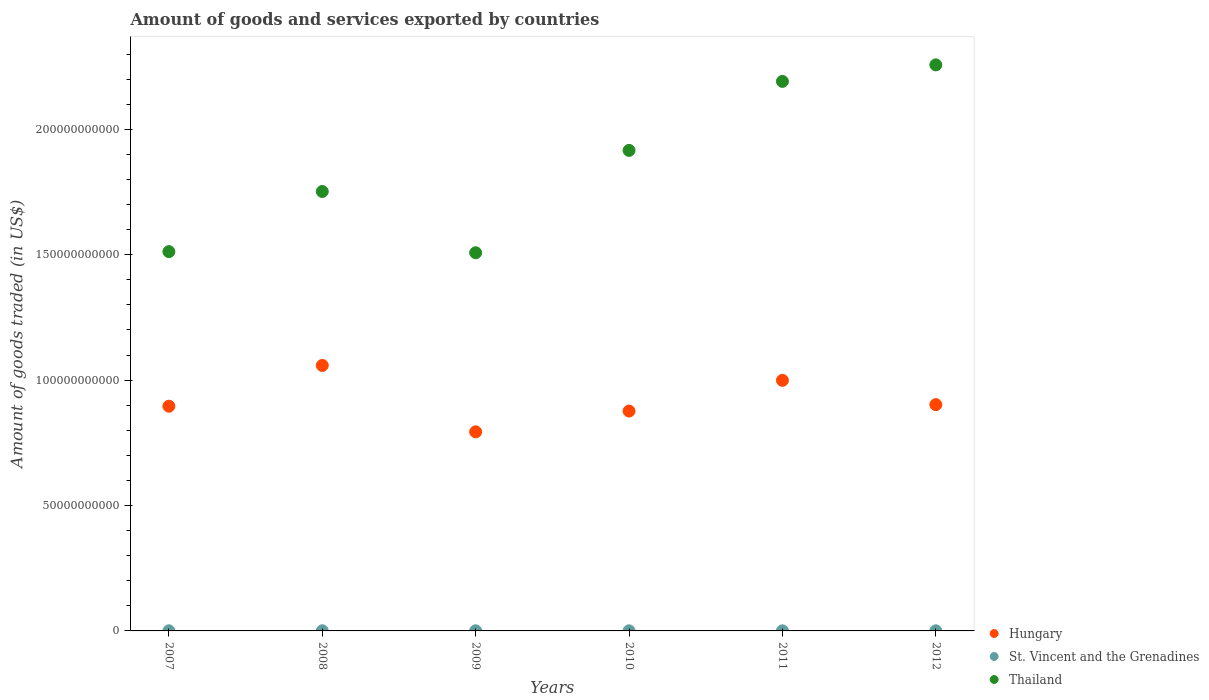How many different coloured dotlines are there?
Offer a terse response. 3. Is the number of dotlines equal to the number of legend labels?
Your answer should be very brief. Yes. What is the total amount of goods and services exported in St. Vincent and the Grenadines in 2012?
Make the answer very short. 4.78e+07. Across all years, what is the maximum total amount of goods and services exported in St. Vincent and the Grenadines?
Provide a succinct answer. 5.72e+07. Across all years, what is the minimum total amount of goods and services exported in St. Vincent and the Grenadines?
Your response must be concise. 4.34e+07. In which year was the total amount of goods and services exported in Thailand minimum?
Ensure brevity in your answer.  2009. What is the total total amount of goods and services exported in St. Vincent and the Grenadines in the graph?
Offer a terse response. 2.98e+08. What is the difference between the total amount of goods and services exported in St. Vincent and the Grenadines in 2009 and that in 2012?
Offer a terse response. 5.57e+06. What is the difference between the total amount of goods and services exported in Hungary in 2009 and the total amount of goods and services exported in St. Vincent and the Grenadines in 2008?
Your answer should be very brief. 7.93e+1. What is the average total amount of goods and services exported in Hungary per year?
Give a very brief answer. 9.21e+1. In the year 2009, what is the difference between the total amount of goods and services exported in St. Vincent and the Grenadines and total amount of goods and services exported in Hungary?
Offer a very short reply. -7.93e+1. What is the ratio of the total amount of goods and services exported in Thailand in 2008 to that in 2009?
Keep it short and to the point. 1.16. Is the difference between the total amount of goods and services exported in St. Vincent and the Grenadines in 2009 and 2012 greater than the difference between the total amount of goods and services exported in Hungary in 2009 and 2012?
Your answer should be very brief. Yes. What is the difference between the highest and the second highest total amount of goods and services exported in St. Vincent and the Grenadines?
Provide a short and direct response. 3.83e+06. What is the difference between the highest and the lowest total amount of goods and services exported in St. Vincent and the Grenadines?
Give a very brief answer. 1.38e+07. In how many years, is the total amount of goods and services exported in Hungary greater than the average total amount of goods and services exported in Hungary taken over all years?
Offer a terse response. 2. Is the sum of the total amount of goods and services exported in Thailand in 2008 and 2010 greater than the maximum total amount of goods and services exported in Hungary across all years?
Ensure brevity in your answer.  Yes. Is it the case that in every year, the sum of the total amount of goods and services exported in Hungary and total amount of goods and services exported in Thailand  is greater than the total amount of goods and services exported in St. Vincent and the Grenadines?
Give a very brief answer. Yes. Is the total amount of goods and services exported in Hungary strictly greater than the total amount of goods and services exported in Thailand over the years?
Give a very brief answer. No. Is the total amount of goods and services exported in Hungary strictly less than the total amount of goods and services exported in St. Vincent and the Grenadines over the years?
Offer a terse response. No. How many dotlines are there?
Your answer should be compact. 3. What is the difference between two consecutive major ticks on the Y-axis?
Your answer should be very brief. 5.00e+1. Does the graph contain grids?
Provide a succinct answer. No. Where does the legend appear in the graph?
Offer a terse response. Bottom right. What is the title of the graph?
Provide a short and direct response. Amount of goods and services exported by countries. Does "Kyrgyz Republic" appear as one of the legend labels in the graph?
Ensure brevity in your answer.  No. What is the label or title of the Y-axis?
Provide a short and direct response. Amount of goods traded (in US$). What is the Amount of goods traded (in US$) in Hungary in 2007?
Keep it short and to the point. 8.96e+1. What is the Amount of goods traded (in US$) of St. Vincent and the Grenadines in 2007?
Your response must be concise. 5.13e+07. What is the Amount of goods traded (in US$) of Thailand in 2007?
Your answer should be very brief. 1.51e+11. What is the Amount of goods traded (in US$) in Hungary in 2008?
Your answer should be very brief. 1.06e+11. What is the Amount of goods traded (in US$) of St. Vincent and the Grenadines in 2008?
Your response must be concise. 5.72e+07. What is the Amount of goods traded (in US$) in Thailand in 2008?
Keep it short and to the point. 1.75e+11. What is the Amount of goods traded (in US$) in Hungary in 2009?
Give a very brief answer. 7.94e+1. What is the Amount of goods traded (in US$) in St. Vincent and the Grenadines in 2009?
Keep it short and to the point. 5.34e+07. What is the Amount of goods traded (in US$) in Thailand in 2009?
Your answer should be compact. 1.51e+11. What is the Amount of goods traded (in US$) in Hungary in 2010?
Ensure brevity in your answer.  8.77e+1. What is the Amount of goods traded (in US$) of St. Vincent and the Grenadines in 2010?
Keep it short and to the point. 4.50e+07. What is the Amount of goods traded (in US$) in Thailand in 2010?
Offer a terse response. 1.92e+11. What is the Amount of goods traded (in US$) of Hungary in 2011?
Give a very brief answer. 9.99e+1. What is the Amount of goods traded (in US$) in St. Vincent and the Grenadines in 2011?
Give a very brief answer. 4.34e+07. What is the Amount of goods traded (in US$) of Thailand in 2011?
Ensure brevity in your answer.  2.19e+11. What is the Amount of goods traded (in US$) of Hungary in 2012?
Your answer should be very brief. 9.02e+1. What is the Amount of goods traded (in US$) of St. Vincent and the Grenadines in 2012?
Keep it short and to the point. 4.78e+07. What is the Amount of goods traded (in US$) in Thailand in 2012?
Ensure brevity in your answer.  2.26e+11. Across all years, what is the maximum Amount of goods traded (in US$) of Hungary?
Provide a succinct answer. 1.06e+11. Across all years, what is the maximum Amount of goods traded (in US$) of St. Vincent and the Grenadines?
Keep it short and to the point. 5.72e+07. Across all years, what is the maximum Amount of goods traded (in US$) in Thailand?
Provide a short and direct response. 2.26e+11. Across all years, what is the minimum Amount of goods traded (in US$) of Hungary?
Your answer should be compact. 7.94e+1. Across all years, what is the minimum Amount of goods traded (in US$) of St. Vincent and the Grenadines?
Provide a short and direct response. 4.34e+07. Across all years, what is the minimum Amount of goods traded (in US$) of Thailand?
Your answer should be very brief. 1.51e+11. What is the total Amount of goods traded (in US$) in Hungary in the graph?
Your answer should be very brief. 5.53e+11. What is the total Amount of goods traded (in US$) of St. Vincent and the Grenadines in the graph?
Provide a short and direct response. 2.98e+08. What is the total Amount of goods traded (in US$) in Thailand in the graph?
Your response must be concise. 1.11e+12. What is the difference between the Amount of goods traded (in US$) in Hungary in 2007 and that in 2008?
Offer a very short reply. -1.63e+1. What is the difference between the Amount of goods traded (in US$) in St. Vincent and the Grenadines in 2007 and that in 2008?
Keep it short and to the point. -5.84e+06. What is the difference between the Amount of goods traded (in US$) in Thailand in 2007 and that in 2008?
Provide a short and direct response. -2.40e+1. What is the difference between the Amount of goods traded (in US$) in Hungary in 2007 and that in 2009?
Make the answer very short. 1.02e+1. What is the difference between the Amount of goods traded (in US$) of St. Vincent and the Grenadines in 2007 and that in 2009?
Your response must be concise. -2.00e+06. What is the difference between the Amount of goods traded (in US$) of Thailand in 2007 and that in 2009?
Provide a succinct answer. 4.52e+08. What is the difference between the Amount of goods traded (in US$) of Hungary in 2007 and that in 2010?
Provide a succinct answer. 1.94e+09. What is the difference between the Amount of goods traded (in US$) in St. Vincent and the Grenadines in 2007 and that in 2010?
Make the answer very short. 6.35e+06. What is the difference between the Amount of goods traded (in US$) of Thailand in 2007 and that in 2010?
Make the answer very short. -4.04e+1. What is the difference between the Amount of goods traded (in US$) in Hungary in 2007 and that in 2011?
Offer a very short reply. -1.03e+1. What is the difference between the Amount of goods traded (in US$) of St. Vincent and the Grenadines in 2007 and that in 2011?
Keep it short and to the point. 7.93e+06. What is the difference between the Amount of goods traded (in US$) of Thailand in 2007 and that in 2011?
Offer a very short reply. -6.79e+1. What is the difference between the Amount of goods traded (in US$) in Hungary in 2007 and that in 2012?
Your answer should be compact. -6.25e+08. What is the difference between the Amount of goods traded (in US$) of St. Vincent and the Grenadines in 2007 and that in 2012?
Keep it short and to the point. 3.56e+06. What is the difference between the Amount of goods traded (in US$) in Thailand in 2007 and that in 2012?
Keep it short and to the point. -7.45e+1. What is the difference between the Amount of goods traded (in US$) of Hungary in 2008 and that in 2009?
Provide a short and direct response. 2.65e+1. What is the difference between the Amount of goods traded (in US$) of St. Vincent and the Grenadines in 2008 and that in 2009?
Provide a succinct answer. 3.83e+06. What is the difference between the Amount of goods traded (in US$) of Thailand in 2008 and that in 2009?
Provide a succinct answer. 2.44e+1. What is the difference between the Amount of goods traded (in US$) in Hungary in 2008 and that in 2010?
Your response must be concise. 1.82e+1. What is the difference between the Amount of goods traded (in US$) in St. Vincent and the Grenadines in 2008 and that in 2010?
Give a very brief answer. 1.22e+07. What is the difference between the Amount of goods traded (in US$) of Thailand in 2008 and that in 2010?
Provide a short and direct response. -1.64e+1. What is the difference between the Amount of goods traded (in US$) of Hungary in 2008 and that in 2011?
Make the answer very short. 5.95e+09. What is the difference between the Amount of goods traded (in US$) of St. Vincent and the Grenadines in 2008 and that in 2011?
Offer a terse response. 1.38e+07. What is the difference between the Amount of goods traded (in US$) of Thailand in 2008 and that in 2011?
Offer a very short reply. -4.39e+1. What is the difference between the Amount of goods traded (in US$) in Hungary in 2008 and that in 2012?
Your answer should be very brief. 1.56e+1. What is the difference between the Amount of goods traded (in US$) in St. Vincent and the Grenadines in 2008 and that in 2012?
Give a very brief answer. 9.40e+06. What is the difference between the Amount of goods traded (in US$) in Thailand in 2008 and that in 2012?
Offer a terse response. -5.05e+1. What is the difference between the Amount of goods traded (in US$) of Hungary in 2009 and that in 2010?
Ensure brevity in your answer.  -8.29e+09. What is the difference between the Amount of goods traded (in US$) of St. Vincent and the Grenadines in 2009 and that in 2010?
Your answer should be very brief. 8.35e+06. What is the difference between the Amount of goods traded (in US$) of Thailand in 2009 and that in 2010?
Give a very brief answer. -4.08e+1. What is the difference between the Amount of goods traded (in US$) of Hungary in 2009 and that in 2011?
Give a very brief answer. -2.05e+1. What is the difference between the Amount of goods traded (in US$) of St. Vincent and the Grenadines in 2009 and that in 2011?
Your answer should be compact. 9.93e+06. What is the difference between the Amount of goods traded (in US$) of Thailand in 2009 and that in 2011?
Offer a terse response. -6.83e+1. What is the difference between the Amount of goods traded (in US$) of Hungary in 2009 and that in 2012?
Provide a succinct answer. -1.08e+1. What is the difference between the Amount of goods traded (in US$) of St. Vincent and the Grenadines in 2009 and that in 2012?
Provide a short and direct response. 5.57e+06. What is the difference between the Amount of goods traded (in US$) of Thailand in 2009 and that in 2012?
Your answer should be compact. -7.49e+1. What is the difference between the Amount of goods traded (in US$) in Hungary in 2010 and that in 2011?
Make the answer very short. -1.22e+1. What is the difference between the Amount of goods traded (in US$) in St. Vincent and the Grenadines in 2010 and that in 2011?
Keep it short and to the point. 1.58e+06. What is the difference between the Amount of goods traded (in US$) of Thailand in 2010 and that in 2011?
Keep it short and to the point. -2.75e+1. What is the difference between the Amount of goods traded (in US$) of Hungary in 2010 and that in 2012?
Give a very brief answer. -2.56e+09. What is the difference between the Amount of goods traded (in US$) of St. Vincent and the Grenadines in 2010 and that in 2012?
Offer a terse response. -2.79e+06. What is the difference between the Amount of goods traded (in US$) of Thailand in 2010 and that in 2012?
Your response must be concise. -3.41e+1. What is the difference between the Amount of goods traded (in US$) in Hungary in 2011 and that in 2012?
Keep it short and to the point. 9.68e+09. What is the difference between the Amount of goods traded (in US$) in St. Vincent and the Grenadines in 2011 and that in 2012?
Give a very brief answer. -4.37e+06. What is the difference between the Amount of goods traded (in US$) in Thailand in 2011 and that in 2012?
Give a very brief answer. -6.58e+09. What is the difference between the Amount of goods traded (in US$) of Hungary in 2007 and the Amount of goods traded (in US$) of St. Vincent and the Grenadines in 2008?
Your answer should be compact. 8.95e+1. What is the difference between the Amount of goods traded (in US$) of Hungary in 2007 and the Amount of goods traded (in US$) of Thailand in 2008?
Offer a terse response. -8.56e+1. What is the difference between the Amount of goods traded (in US$) of St. Vincent and the Grenadines in 2007 and the Amount of goods traded (in US$) of Thailand in 2008?
Keep it short and to the point. -1.75e+11. What is the difference between the Amount of goods traded (in US$) of Hungary in 2007 and the Amount of goods traded (in US$) of St. Vincent and the Grenadines in 2009?
Provide a short and direct response. 8.96e+1. What is the difference between the Amount of goods traded (in US$) of Hungary in 2007 and the Amount of goods traded (in US$) of Thailand in 2009?
Make the answer very short. -6.12e+1. What is the difference between the Amount of goods traded (in US$) in St. Vincent and the Grenadines in 2007 and the Amount of goods traded (in US$) in Thailand in 2009?
Make the answer very short. -1.51e+11. What is the difference between the Amount of goods traded (in US$) of Hungary in 2007 and the Amount of goods traded (in US$) of St. Vincent and the Grenadines in 2010?
Offer a very short reply. 8.96e+1. What is the difference between the Amount of goods traded (in US$) of Hungary in 2007 and the Amount of goods traded (in US$) of Thailand in 2010?
Your response must be concise. -1.02e+11. What is the difference between the Amount of goods traded (in US$) in St. Vincent and the Grenadines in 2007 and the Amount of goods traded (in US$) in Thailand in 2010?
Offer a very short reply. -1.92e+11. What is the difference between the Amount of goods traded (in US$) of Hungary in 2007 and the Amount of goods traded (in US$) of St. Vincent and the Grenadines in 2011?
Your answer should be compact. 8.96e+1. What is the difference between the Amount of goods traded (in US$) in Hungary in 2007 and the Amount of goods traded (in US$) in Thailand in 2011?
Offer a terse response. -1.30e+11. What is the difference between the Amount of goods traded (in US$) of St. Vincent and the Grenadines in 2007 and the Amount of goods traded (in US$) of Thailand in 2011?
Ensure brevity in your answer.  -2.19e+11. What is the difference between the Amount of goods traded (in US$) of Hungary in 2007 and the Amount of goods traded (in US$) of St. Vincent and the Grenadines in 2012?
Keep it short and to the point. 8.96e+1. What is the difference between the Amount of goods traded (in US$) in Hungary in 2007 and the Amount of goods traded (in US$) in Thailand in 2012?
Your answer should be very brief. -1.36e+11. What is the difference between the Amount of goods traded (in US$) in St. Vincent and the Grenadines in 2007 and the Amount of goods traded (in US$) in Thailand in 2012?
Keep it short and to the point. -2.26e+11. What is the difference between the Amount of goods traded (in US$) in Hungary in 2008 and the Amount of goods traded (in US$) in St. Vincent and the Grenadines in 2009?
Offer a terse response. 1.06e+11. What is the difference between the Amount of goods traded (in US$) in Hungary in 2008 and the Amount of goods traded (in US$) in Thailand in 2009?
Your answer should be compact. -4.49e+1. What is the difference between the Amount of goods traded (in US$) of St. Vincent and the Grenadines in 2008 and the Amount of goods traded (in US$) of Thailand in 2009?
Ensure brevity in your answer.  -1.51e+11. What is the difference between the Amount of goods traded (in US$) of Hungary in 2008 and the Amount of goods traded (in US$) of St. Vincent and the Grenadines in 2010?
Your response must be concise. 1.06e+11. What is the difference between the Amount of goods traded (in US$) of Hungary in 2008 and the Amount of goods traded (in US$) of Thailand in 2010?
Provide a succinct answer. -8.57e+1. What is the difference between the Amount of goods traded (in US$) of St. Vincent and the Grenadines in 2008 and the Amount of goods traded (in US$) of Thailand in 2010?
Offer a terse response. -1.92e+11. What is the difference between the Amount of goods traded (in US$) in Hungary in 2008 and the Amount of goods traded (in US$) in St. Vincent and the Grenadines in 2011?
Make the answer very short. 1.06e+11. What is the difference between the Amount of goods traded (in US$) in Hungary in 2008 and the Amount of goods traded (in US$) in Thailand in 2011?
Give a very brief answer. -1.13e+11. What is the difference between the Amount of goods traded (in US$) of St. Vincent and the Grenadines in 2008 and the Amount of goods traded (in US$) of Thailand in 2011?
Ensure brevity in your answer.  -2.19e+11. What is the difference between the Amount of goods traded (in US$) in Hungary in 2008 and the Amount of goods traded (in US$) in St. Vincent and the Grenadines in 2012?
Ensure brevity in your answer.  1.06e+11. What is the difference between the Amount of goods traded (in US$) of Hungary in 2008 and the Amount of goods traded (in US$) of Thailand in 2012?
Give a very brief answer. -1.20e+11. What is the difference between the Amount of goods traded (in US$) in St. Vincent and the Grenadines in 2008 and the Amount of goods traded (in US$) in Thailand in 2012?
Offer a terse response. -2.26e+11. What is the difference between the Amount of goods traded (in US$) in Hungary in 2009 and the Amount of goods traded (in US$) in St. Vincent and the Grenadines in 2010?
Your response must be concise. 7.93e+1. What is the difference between the Amount of goods traded (in US$) in Hungary in 2009 and the Amount of goods traded (in US$) in Thailand in 2010?
Provide a short and direct response. -1.12e+11. What is the difference between the Amount of goods traded (in US$) of St. Vincent and the Grenadines in 2009 and the Amount of goods traded (in US$) of Thailand in 2010?
Give a very brief answer. -1.92e+11. What is the difference between the Amount of goods traded (in US$) of Hungary in 2009 and the Amount of goods traded (in US$) of St. Vincent and the Grenadines in 2011?
Give a very brief answer. 7.93e+1. What is the difference between the Amount of goods traded (in US$) of Hungary in 2009 and the Amount of goods traded (in US$) of Thailand in 2011?
Ensure brevity in your answer.  -1.40e+11. What is the difference between the Amount of goods traded (in US$) of St. Vincent and the Grenadines in 2009 and the Amount of goods traded (in US$) of Thailand in 2011?
Offer a very short reply. -2.19e+11. What is the difference between the Amount of goods traded (in US$) of Hungary in 2009 and the Amount of goods traded (in US$) of St. Vincent and the Grenadines in 2012?
Your answer should be very brief. 7.93e+1. What is the difference between the Amount of goods traded (in US$) of Hungary in 2009 and the Amount of goods traded (in US$) of Thailand in 2012?
Provide a succinct answer. -1.46e+11. What is the difference between the Amount of goods traded (in US$) in St. Vincent and the Grenadines in 2009 and the Amount of goods traded (in US$) in Thailand in 2012?
Keep it short and to the point. -2.26e+11. What is the difference between the Amount of goods traded (in US$) in Hungary in 2010 and the Amount of goods traded (in US$) in St. Vincent and the Grenadines in 2011?
Your answer should be very brief. 8.76e+1. What is the difference between the Amount of goods traded (in US$) of Hungary in 2010 and the Amount of goods traded (in US$) of Thailand in 2011?
Keep it short and to the point. -1.31e+11. What is the difference between the Amount of goods traded (in US$) in St. Vincent and the Grenadines in 2010 and the Amount of goods traded (in US$) in Thailand in 2011?
Provide a succinct answer. -2.19e+11. What is the difference between the Amount of goods traded (in US$) of Hungary in 2010 and the Amount of goods traded (in US$) of St. Vincent and the Grenadines in 2012?
Your answer should be compact. 8.76e+1. What is the difference between the Amount of goods traded (in US$) in Hungary in 2010 and the Amount of goods traded (in US$) in Thailand in 2012?
Provide a short and direct response. -1.38e+11. What is the difference between the Amount of goods traded (in US$) in St. Vincent and the Grenadines in 2010 and the Amount of goods traded (in US$) in Thailand in 2012?
Keep it short and to the point. -2.26e+11. What is the difference between the Amount of goods traded (in US$) in Hungary in 2011 and the Amount of goods traded (in US$) in St. Vincent and the Grenadines in 2012?
Provide a succinct answer. 9.99e+1. What is the difference between the Amount of goods traded (in US$) in Hungary in 2011 and the Amount of goods traded (in US$) in Thailand in 2012?
Your answer should be very brief. -1.26e+11. What is the difference between the Amount of goods traded (in US$) in St. Vincent and the Grenadines in 2011 and the Amount of goods traded (in US$) in Thailand in 2012?
Give a very brief answer. -2.26e+11. What is the average Amount of goods traded (in US$) in Hungary per year?
Give a very brief answer. 9.21e+1. What is the average Amount of goods traded (in US$) in St. Vincent and the Grenadines per year?
Provide a short and direct response. 4.97e+07. What is the average Amount of goods traded (in US$) of Thailand per year?
Offer a very short reply. 1.86e+11. In the year 2007, what is the difference between the Amount of goods traded (in US$) of Hungary and Amount of goods traded (in US$) of St. Vincent and the Grenadines?
Offer a terse response. 8.96e+1. In the year 2007, what is the difference between the Amount of goods traded (in US$) in Hungary and Amount of goods traded (in US$) in Thailand?
Provide a short and direct response. -6.16e+1. In the year 2007, what is the difference between the Amount of goods traded (in US$) in St. Vincent and the Grenadines and Amount of goods traded (in US$) in Thailand?
Offer a terse response. -1.51e+11. In the year 2008, what is the difference between the Amount of goods traded (in US$) in Hungary and Amount of goods traded (in US$) in St. Vincent and the Grenadines?
Provide a short and direct response. 1.06e+11. In the year 2008, what is the difference between the Amount of goods traded (in US$) in Hungary and Amount of goods traded (in US$) in Thailand?
Your answer should be compact. -6.94e+1. In the year 2008, what is the difference between the Amount of goods traded (in US$) of St. Vincent and the Grenadines and Amount of goods traded (in US$) of Thailand?
Offer a terse response. -1.75e+11. In the year 2009, what is the difference between the Amount of goods traded (in US$) in Hungary and Amount of goods traded (in US$) in St. Vincent and the Grenadines?
Provide a succinct answer. 7.93e+1. In the year 2009, what is the difference between the Amount of goods traded (in US$) of Hungary and Amount of goods traded (in US$) of Thailand?
Give a very brief answer. -7.14e+1. In the year 2009, what is the difference between the Amount of goods traded (in US$) of St. Vincent and the Grenadines and Amount of goods traded (in US$) of Thailand?
Your response must be concise. -1.51e+11. In the year 2010, what is the difference between the Amount of goods traded (in US$) of Hungary and Amount of goods traded (in US$) of St. Vincent and the Grenadines?
Provide a succinct answer. 8.76e+1. In the year 2010, what is the difference between the Amount of goods traded (in US$) of Hungary and Amount of goods traded (in US$) of Thailand?
Provide a succinct answer. -1.04e+11. In the year 2010, what is the difference between the Amount of goods traded (in US$) of St. Vincent and the Grenadines and Amount of goods traded (in US$) of Thailand?
Your answer should be compact. -1.92e+11. In the year 2011, what is the difference between the Amount of goods traded (in US$) in Hungary and Amount of goods traded (in US$) in St. Vincent and the Grenadines?
Your answer should be very brief. 9.99e+1. In the year 2011, what is the difference between the Amount of goods traded (in US$) in Hungary and Amount of goods traded (in US$) in Thailand?
Give a very brief answer. -1.19e+11. In the year 2011, what is the difference between the Amount of goods traded (in US$) in St. Vincent and the Grenadines and Amount of goods traded (in US$) in Thailand?
Your response must be concise. -2.19e+11. In the year 2012, what is the difference between the Amount of goods traded (in US$) of Hungary and Amount of goods traded (in US$) of St. Vincent and the Grenadines?
Give a very brief answer. 9.02e+1. In the year 2012, what is the difference between the Amount of goods traded (in US$) of Hungary and Amount of goods traded (in US$) of Thailand?
Ensure brevity in your answer.  -1.35e+11. In the year 2012, what is the difference between the Amount of goods traded (in US$) in St. Vincent and the Grenadines and Amount of goods traded (in US$) in Thailand?
Provide a short and direct response. -2.26e+11. What is the ratio of the Amount of goods traded (in US$) of Hungary in 2007 to that in 2008?
Keep it short and to the point. 0.85. What is the ratio of the Amount of goods traded (in US$) of St. Vincent and the Grenadines in 2007 to that in 2008?
Keep it short and to the point. 0.9. What is the ratio of the Amount of goods traded (in US$) of Thailand in 2007 to that in 2008?
Provide a succinct answer. 0.86. What is the ratio of the Amount of goods traded (in US$) in Hungary in 2007 to that in 2009?
Ensure brevity in your answer.  1.13. What is the ratio of the Amount of goods traded (in US$) in St. Vincent and the Grenadines in 2007 to that in 2009?
Your answer should be very brief. 0.96. What is the ratio of the Amount of goods traded (in US$) of Thailand in 2007 to that in 2009?
Your answer should be compact. 1. What is the ratio of the Amount of goods traded (in US$) of Hungary in 2007 to that in 2010?
Provide a short and direct response. 1.02. What is the ratio of the Amount of goods traded (in US$) in St. Vincent and the Grenadines in 2007 to that in 2010?
Offer a terse response. 1.14. What is the ratio of the Amount of goods traded (in US$) of Thailand in 2007 to that in 2010?
Ensure brevity in your answer.  0.79. What is the ratio of the Amount of goods traded (in US$) of Hungary in 2007 to that in 2011?
Give a very brief answer. 0.9. What is the ratio of the Amount of goods traded (in US$) of St. Vincent and the Grenadines in 2007 to that in 2011?
Keep it short and to the point. 1.18. What is the ratio of the Amount of goods traded (in US$) in Thailand in 2007 to that in 2011?
Provide a succinct answer. 0.69. What is the ratio of the Amount of goods traded (in US$) of Hungary in 2007 to that in 2012?
Your answer should be compact. 0.99. What is the ratio of the Amount of goods traded (in US$) of St. Vincent and the Grenadines in 2007 to that in 2012?
Make the answer very short. 1.07. What is the ratio of the Amount of goods traded (in US$) in Thailand in 2007 to that in 2012?
Make the answer very short. 0.67. What is the ratio of the Amount of goods traded (in US$) in Hungary in 2008 to that in 2009?
Offer a terse response. 1.33. What is the ratio of the Amount of goods traded (in US$) of St. Vincent and the Grenadines in 2008 to that in 2009?
Your answer should be very brief. 1.07. What is the ratio of the Amount of goods traded (in US$) of Thailand in 2008 to that in 2009?
Keep it short and to the point. 1.16. What is the ratio of the Amount of goods traded (in US$) of Hungary in 2008 to that in 2010?
Offer a terse response. 1.21. What is the ratio of the Amount of goods traded (in US$) in St. Vincent and the Grenadines in 2008 to that in 2010?
Your response must be concise. 1.27. What is the ratio of the Amount of goods traded (in US$) of Thailand in 2008 to that in 2010?
Your answer should be compact. 0.91. What is the ratio of the Amount of goods traded (in US$) of Hungary in 2008 to that in 2011?
Your response must be concise. 1.06. What is the ratio of the Amount of goods traded (in US$) in St. Vincent and the Grenadines in 2008 to that in 2011?
Your answer should be very brief. 1.32. What is the ratio of the Amount of goods traded (in US$) in Thailand in 2008 to that in 2011?
Your answer should be very brief. 0.8. What is the ratio of the Amount of goods traded (in US$) of Hungary in 2008 to that in 2012?
Make the answer very short. 1.17. What is the ratio of the Amount of goods traded (in US$) of St. Vincent and the Grenadines in 2008 to that in 2012?
Give a very brief answer. 1.2. What is the ratio of the Amount of goods traded (in US$) in Thailand in 2008 to that in 2012?
Your answer should be very brief. 0.78. What is the ratio of the Amount of goods traded (in US$) in Hungary in 2009 to that in 2010?
Offer a terse response. 0.91. What is the ratio of the Amount of goods traded (in US$) of St. Vincent and the Grenadines in 2009 to that in 2010?
Your response must be concise. 1.19. What is the ratio of the Amount of goods traded (in US$) of Thailand in 2009 to that in 2010?
Offer a terse response. 0.79. What is the ratio of the Amount of goods traded (in US$) of Hungary in 2009 to that in 2011?
Your answer should be compact. 0.79. What is the ratio of the Amount of goods traded (in US$) of St. Vincent and the Grenadines in 2009 to that in 2011?
Give a very brief answer. 1.23. What is the ratio of the Amount of goods traded (in US$) in Thailand in 2009 to that in 2011?
Provide a short and direct response. 0.69. What is the ratio of the Amount of goods traded (in US$) in Hungary in 2009 to that in 2012?
Your response must be concise. 0.88. What is the ratio of the Amount of goods traded (in US$) of St. Vincent and the Grenadines in 2009 to that in 2012?
Offer a very short reply. 1.12. What is the ratio of the Amount of goods traded (in US$) of Thailand in 2009 to that in 2012?
Make the answer very short. 0.67. What is the ratio of the Amount of goods traded (in US$) of Hungary in 2010 to that in 2011?
Your response must be concise. 0.88. What is the ratio of the Amount of goods traded (in US$) in St. Vincent and the Grenadines in 2010 to that in 2011?
Ensure brevity in your answer.  1.04. What is the ratio of the Amount of goods traded (in US$) in Thailand in 2010 to that in 2011?
Your answer should be very brief. 0.87. What is the ratio of the Amount of goods traded (in US$) of Hungary in 2010 to that in 2012?
Offer a terse response. 0.97. What is the ratio of the Amount of goods traded (in US$) in St. Vincent and the Grenadines in 2010 to that in 2012?
Your answer should be very brief. 0.94. What is the ratio of the Amount of goods traded (in US$) in Thailand in 2010 to that in 2012?
Ensure brevity in your answer.  0.85. What is the ratio of the Amount of goods traded (in US$) in Hungary in 2011 to that in 2012?
Provide a succinct answer. 1.11. What is the ratio of the Amount of goods traded (in US$) in St. Vincent and the Grenadines in 2011 to that in 2012?
Provide a short and direct response. 0.91. What is the ratio of the Amount of goods traded (in US$) of Thailand in 2011 to that in 2012?
Provide a succinct answer. 0.97. What is the difference between the highest and the second highest Amount of goods traded (in US$) in Hungary?
Offer a terse response. 5.95e+09. What is the difference between the highest and the second highest Amount of goods traded (in US$) in St. Vincent and the Grenadines?
Provide a short and direct response. 3.83e+06. What is the difference between the highest and the second highest Amount of goods traded (in US$) of Thailand?
Your response must be concise. 6.58e+09. What is the difference between the highest and the lowest Amount of goods traded (in US$) in Hungary?
Offer a terse response. 2.65e+1. What is the difference between the highest and the lowest Amount of goods traded (in US$) of St. Vincent and the Grenadines?
Your answer should be compact. 1.38e+07. What is the difference between the highest and the lowest Amount of goods traded (in US$) in Thailand?
Make the answer very short. 7.49e+1. 